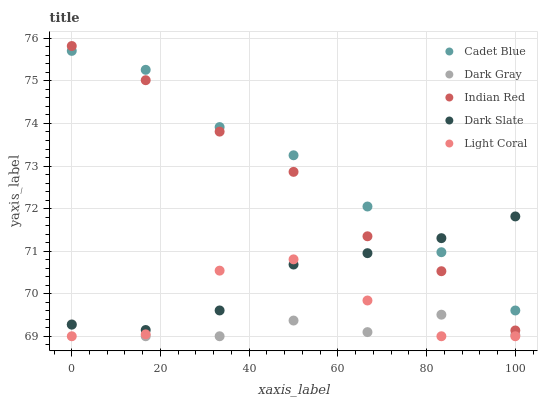Does Dark Gray have the minimum area under the curve?
Answer yes or no. Yes. Does Cadet Blue have the maximum area under the curve?
Answer yes or no. Yes. Does Dark Slate have the minimum area under the curve?
Answer yes or no. No. Does Dark Slate have the maximum area under the curve?
Answer yes or no. No. Is Dark Slate the smoothest?
Answer yes or no. Yes. Is Light Coral the roughest?
Answer yes or no. Yes. Is Light Coral the smoothest?
Answer yes or no. No. Is Dark Slate the roughest?
Answer yes or no. No. Does Dark Gray have the lowest value?
Answer yes or no. Yes. Does Dark Slate have the lowest value?
Answer yes or no. No. Does Indian Red have the highest value?
Answer yes or no. Yes. Does Dark Slate have the highest value?
Answer yes or no. No. Is Dark Gray less than Indian Red?
Answer yes or no. Yes. Is Cadet Blue greater than Dark Gray?
Answer yes or no. Yes. Does Cadet Blue intersect Indian Red?
Answer yes or no. Yes. Is Cadet Blue less than Indian Red?
Answer yes or no. No. Is Cadet Blue greater than Indian Red?
Answer yes or no. No. Does Dark Gray intersect Indian Red?
Answer yes or no. No. 